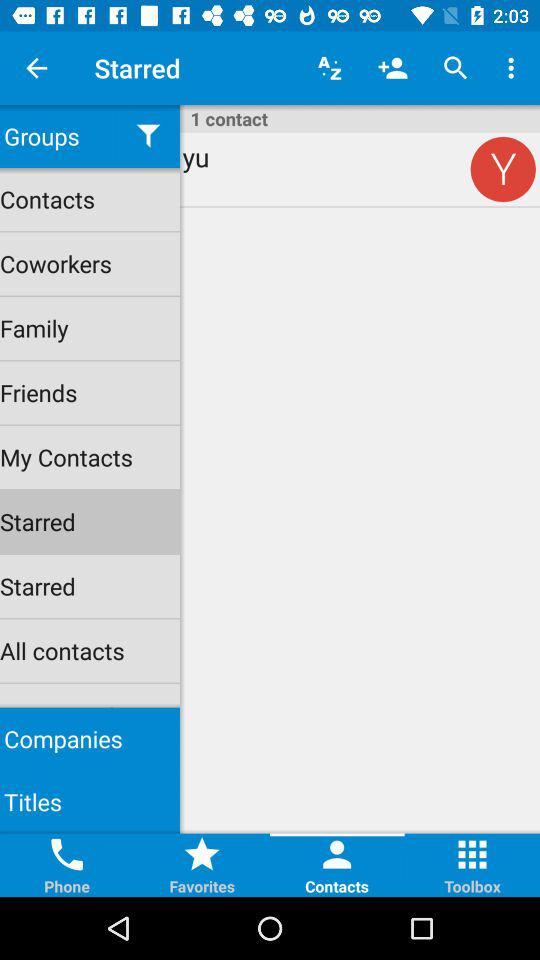Which tab has been selected at the bottom? The selected tab is "Contacts". 